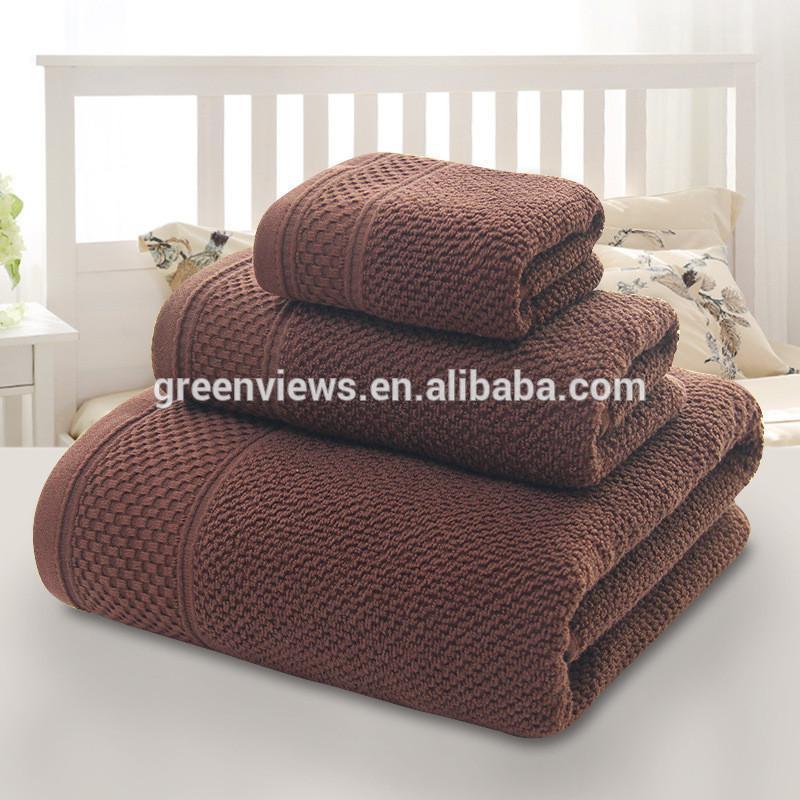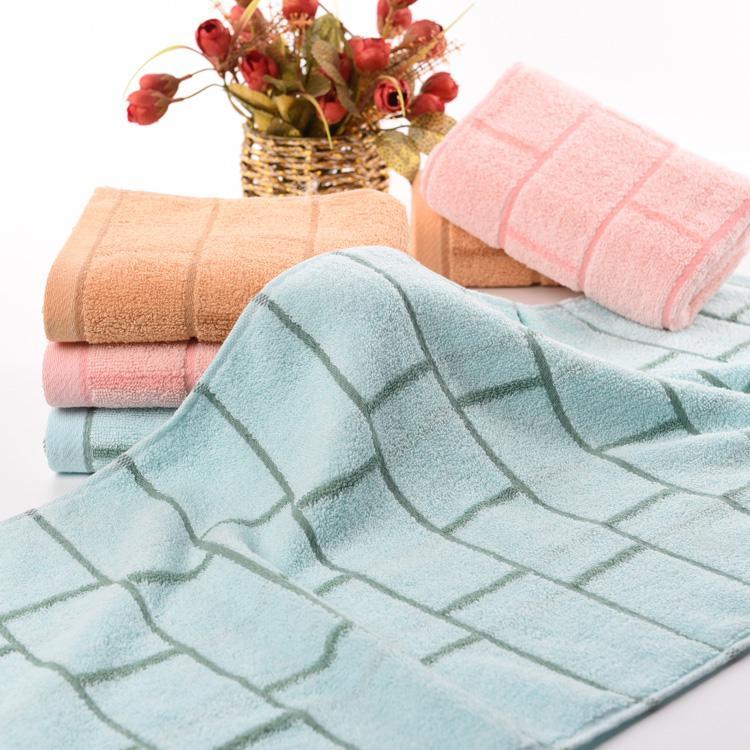The first image is the image on the left, the second image is the image on the right. Analyze the images presented: Is the assertion "There are exactly three folded towels in at least one image." valid? Answer yes or no. Yes. The first image is the image on the left, the second image is the image on the right. Given the left and right images, does the statement "There is exactly one yellow towel." hold true? Answer yes or no. No. 